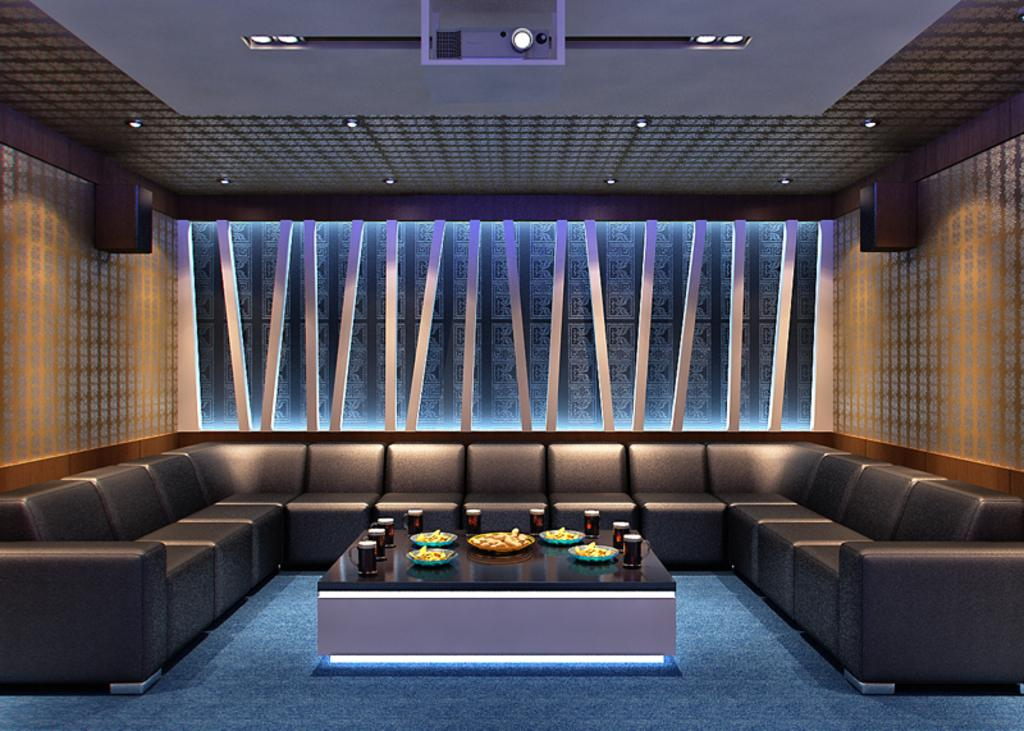What type of room is shown in the image? The image depicts a living room. What furniture is present in the living room? There is a sofa set in the living room. What other piece of furniture can be seen in the living room? There is a table in the living room. What items are on the table in the image? There are cups and food items on the table. What type of fowl is sitting on the sofa in the image? There is no fowl present on the sofa in the image. What type of lettuce is being used as a tablecloth in the image? There is no lettuce present in the image, and it is not being used as a tablecloth. 